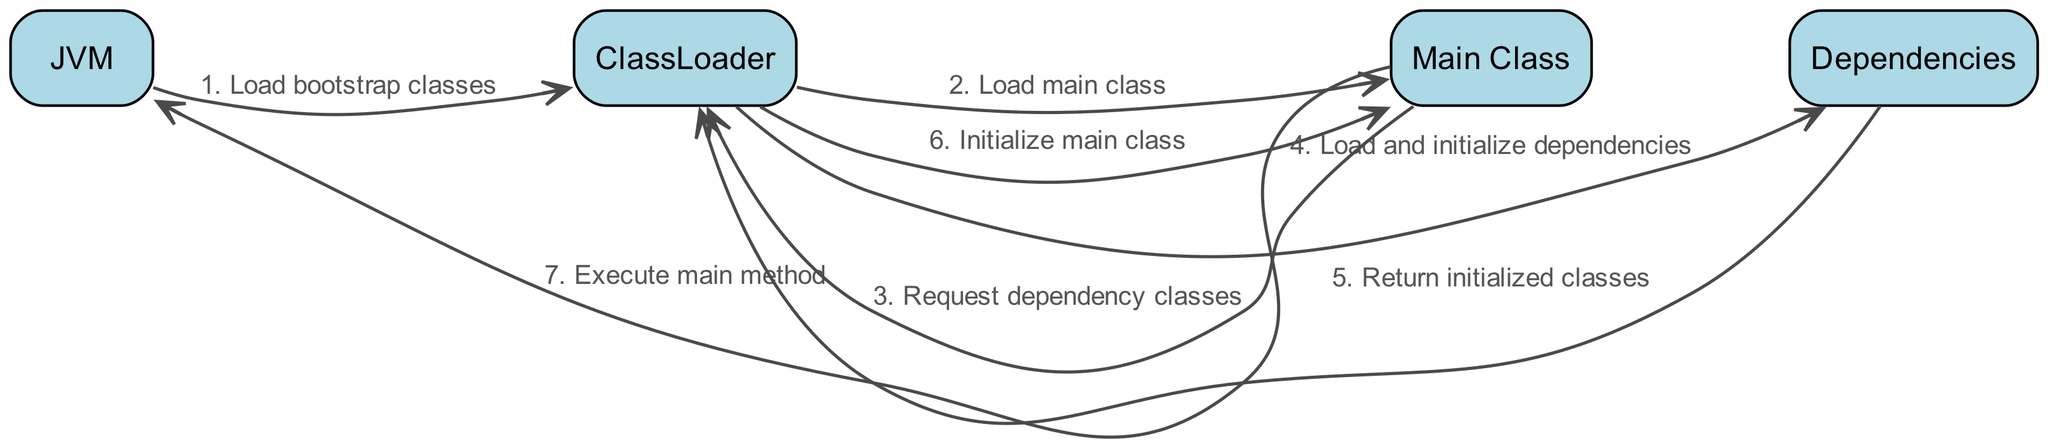What component initiates the loading of bootstrap classes? The diagram shows that the JVM is responsible for initiating the loading of bootstrap classes, which is the first step in the sequence of the Java application startup process.
Answer: JVM How many main classes are represented in the diagram? The diagram indicates that there is only one Main Class involved in the sequence of events, as it is mentioned explicitly in the loading process.
Answer: One What message is sent from the Main Class to the ClassLoader? The Main Class sends a request for dependency classes to the ClassLoader, as shown in one of the steps of the sequence.
Answer: Request dependency classes Which actor returns initialized classes to the ClassLoader? The Dependencies actor is responsible for returning the initialized classes back to the ClassLoader, as indicated in the corresponding step of the sequence.
Answer: Dependencies What is the final action taken after the main class is initialized? After the Main Class is initialized, the next action is to execute the main method, which involves communication from the Main Class to the JVM.
Answer: Execute main method What happens immediately after the ClassLoader loads the main class? Following the loading of the Main Class, the ClassLoader initializes the Main Class, which is depicted as a subsequent step in the sequence.
Answer: Initialize main class What is the total number of actors involved in this sequence diagram? The diagram details a total of four distinct actors involved in the startup process: JVM, ClassLoader, Main Class, and Dependencies.
Answer: Four Which component first interacts with the ClassLoader? The ClassLoader first interacts with the JVM, which triggers the loading of bootstrap classes, marking the start of the sequence.
Answer: JVM 